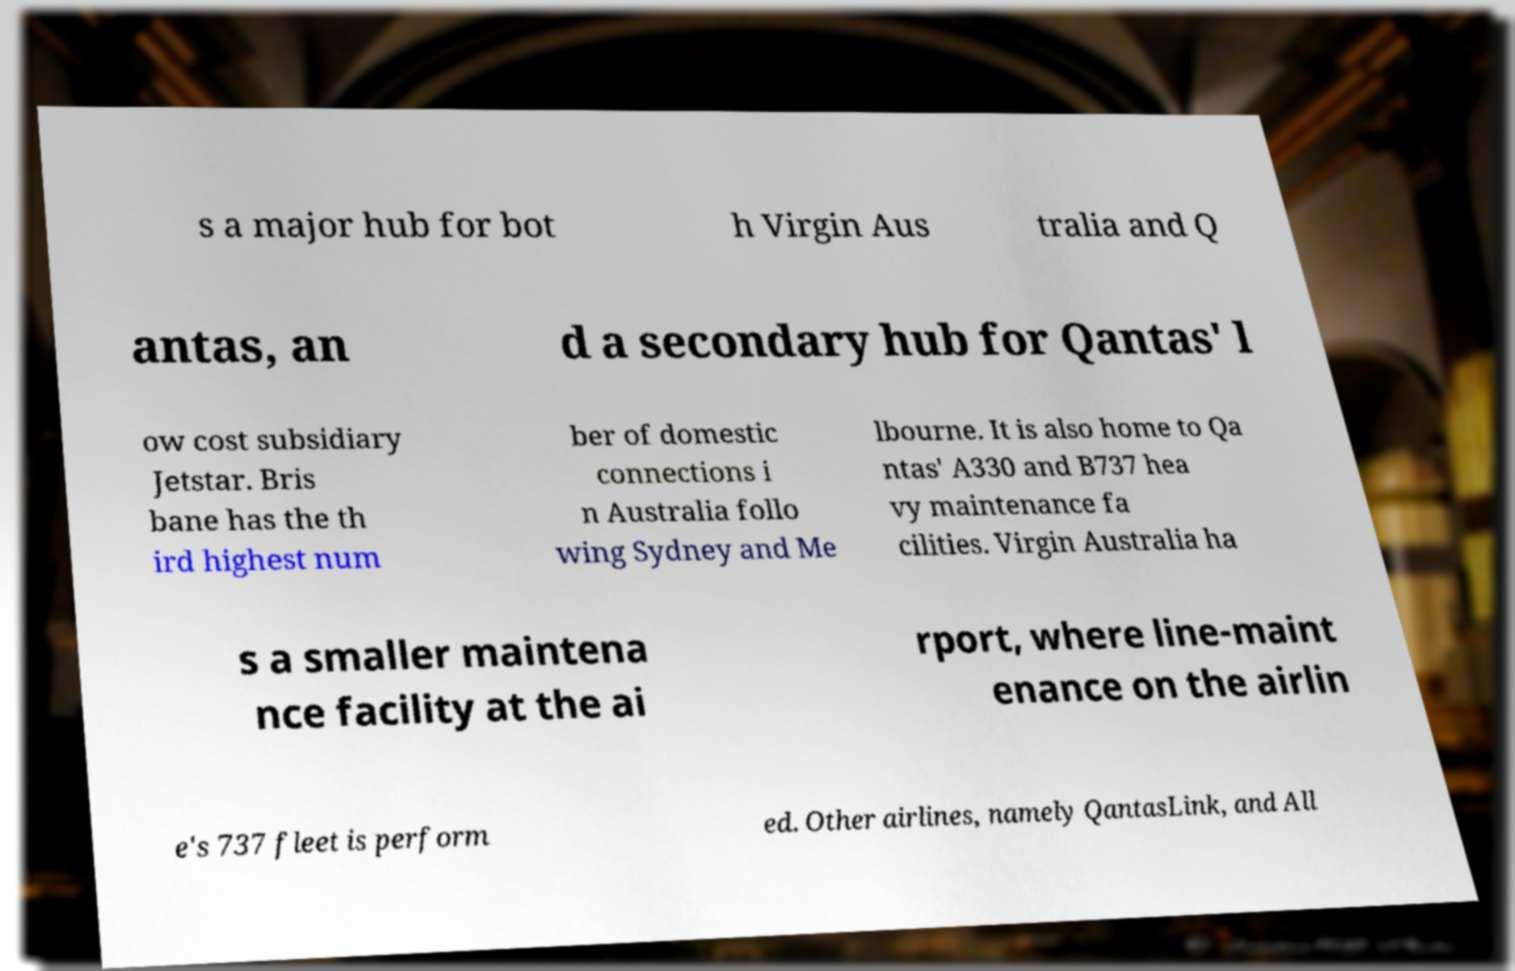Could you extract and type out the text from this image? s a major hub for bot h Virgin Aus tralia and Q antas, an d a secondary hub for Qantas' l ow cost subsidiary Jetstar. Bris bane has the th ird highest num ber of domestic connections i n Australia follo wing Sydney and Me lbourne. It is also home to Qa ntas' A330 and B737 hea vy maintenance fa cilities. Virgin Australia ha s a smaller maintena nce facility at the ai rport, where line-maint enance on the airlin e's 737 fleet is perform ed. Other airlines, namely QantasLink, and All 